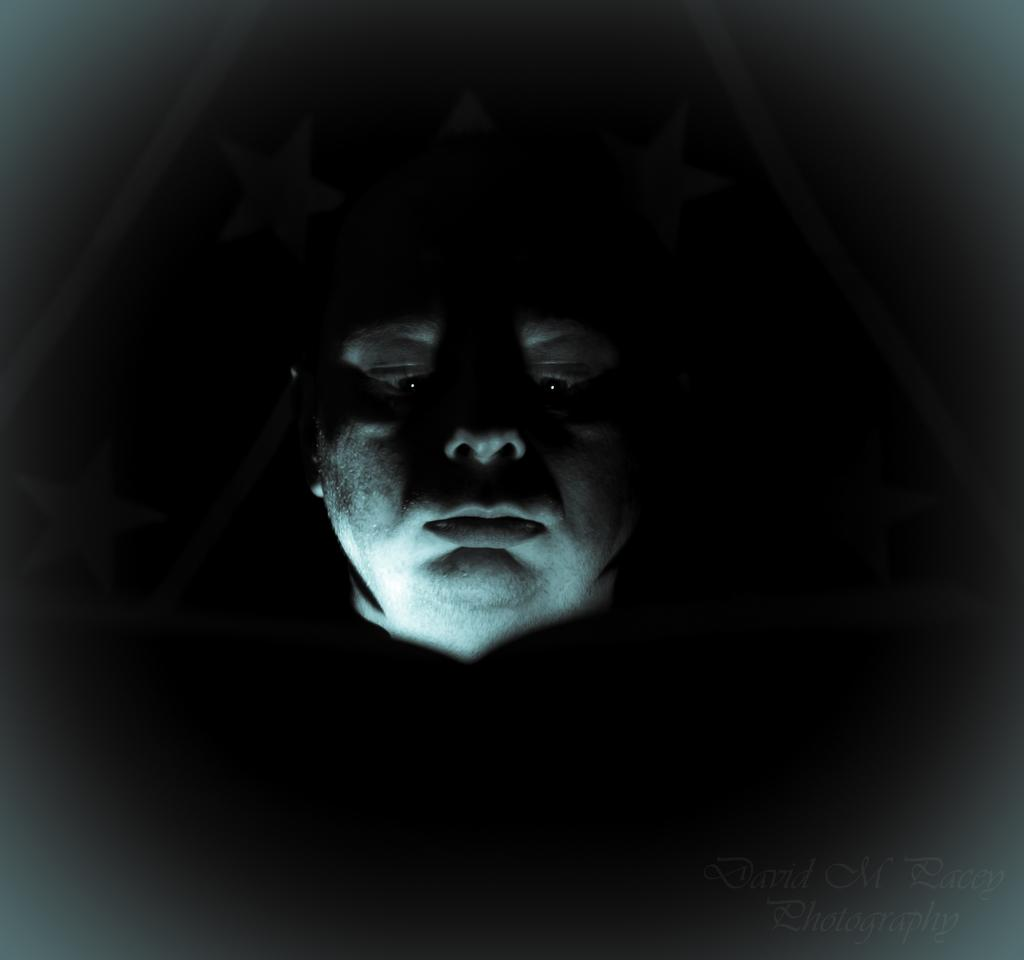What is the main subject of the image? There is a person's face in the image. Can you describe the background of the image? The background of the image is dark. What type of locket is hanging from the person's neck in the image? There is no locket visible in the image; only the person's face is present. How does the quilt contribute to the overall atmosphere of the image? There is no quilt present in the image, so it cannot contribute to the atmosphere. 